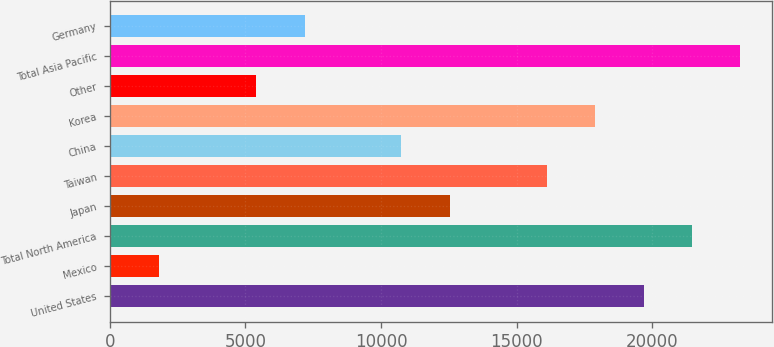Convert chart. <chart><loc_0><loc_0><loc_500><loc_500><bar_chart><fcel>United States<fcel>Mexico<fcel>Total North America<fcel>Japan<fcel>Taiwan<fcel>China<fcel>Korea<fcel>Other<fcel>Total Asia Pacific<fcel>Germany<nl><fcel>19672.1<fcel>1831.1<fcel>21456.2<fcel>12535.7<fcel>16103.9<fcel>10751.6<fcel>17888<fcel>5399.3<fcel>23240.3<fcel>7183.4<nl></chart> 